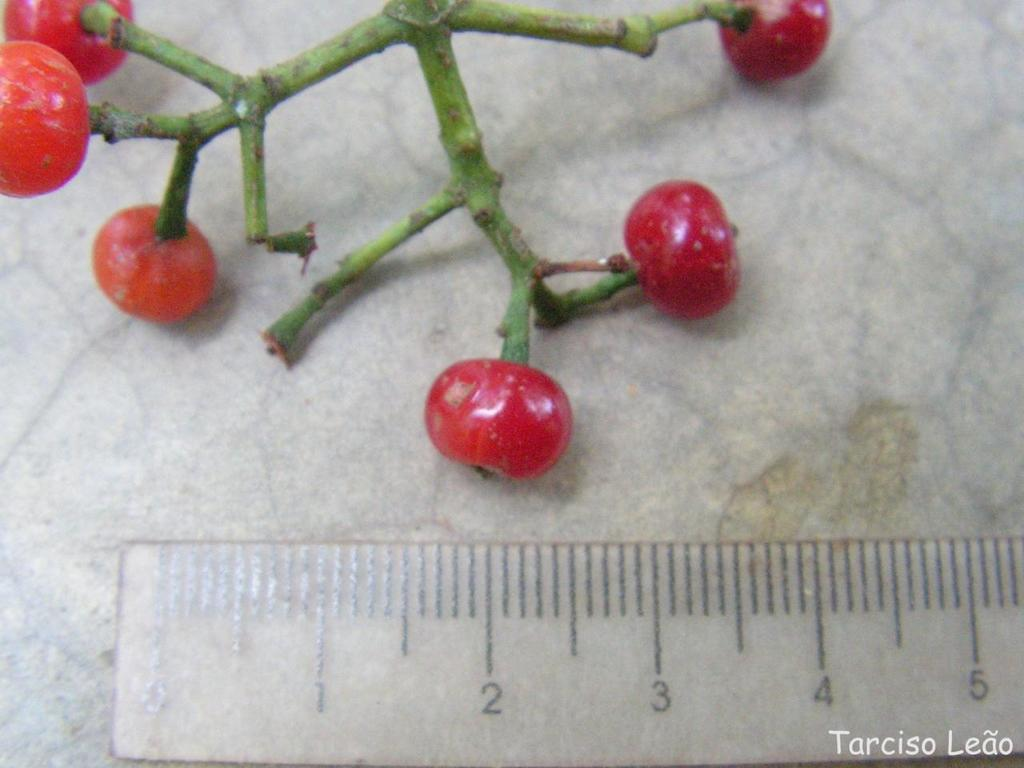<image>
Give a short and clear explanation of the subsequent image. At the bottom right of this picture of some kind of fruit being measured, it says Tarciso Leao. 